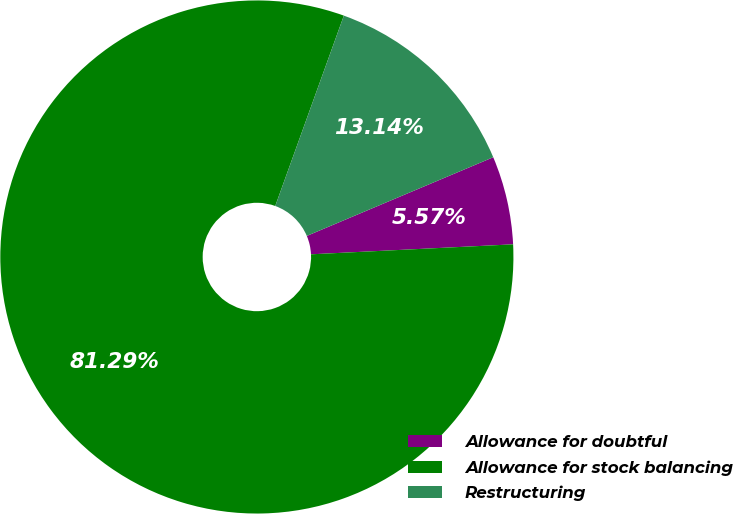<chart> <loc_0><loc_0><loc_500><loc_500><pie_chart><fcel>Allowance for doubtful<fcel>Allowance for stock balancing<fcel>Restructuring<nl><fcel>5.57%<fcel>81.29%<fcel>13.14%<nl></chart> 